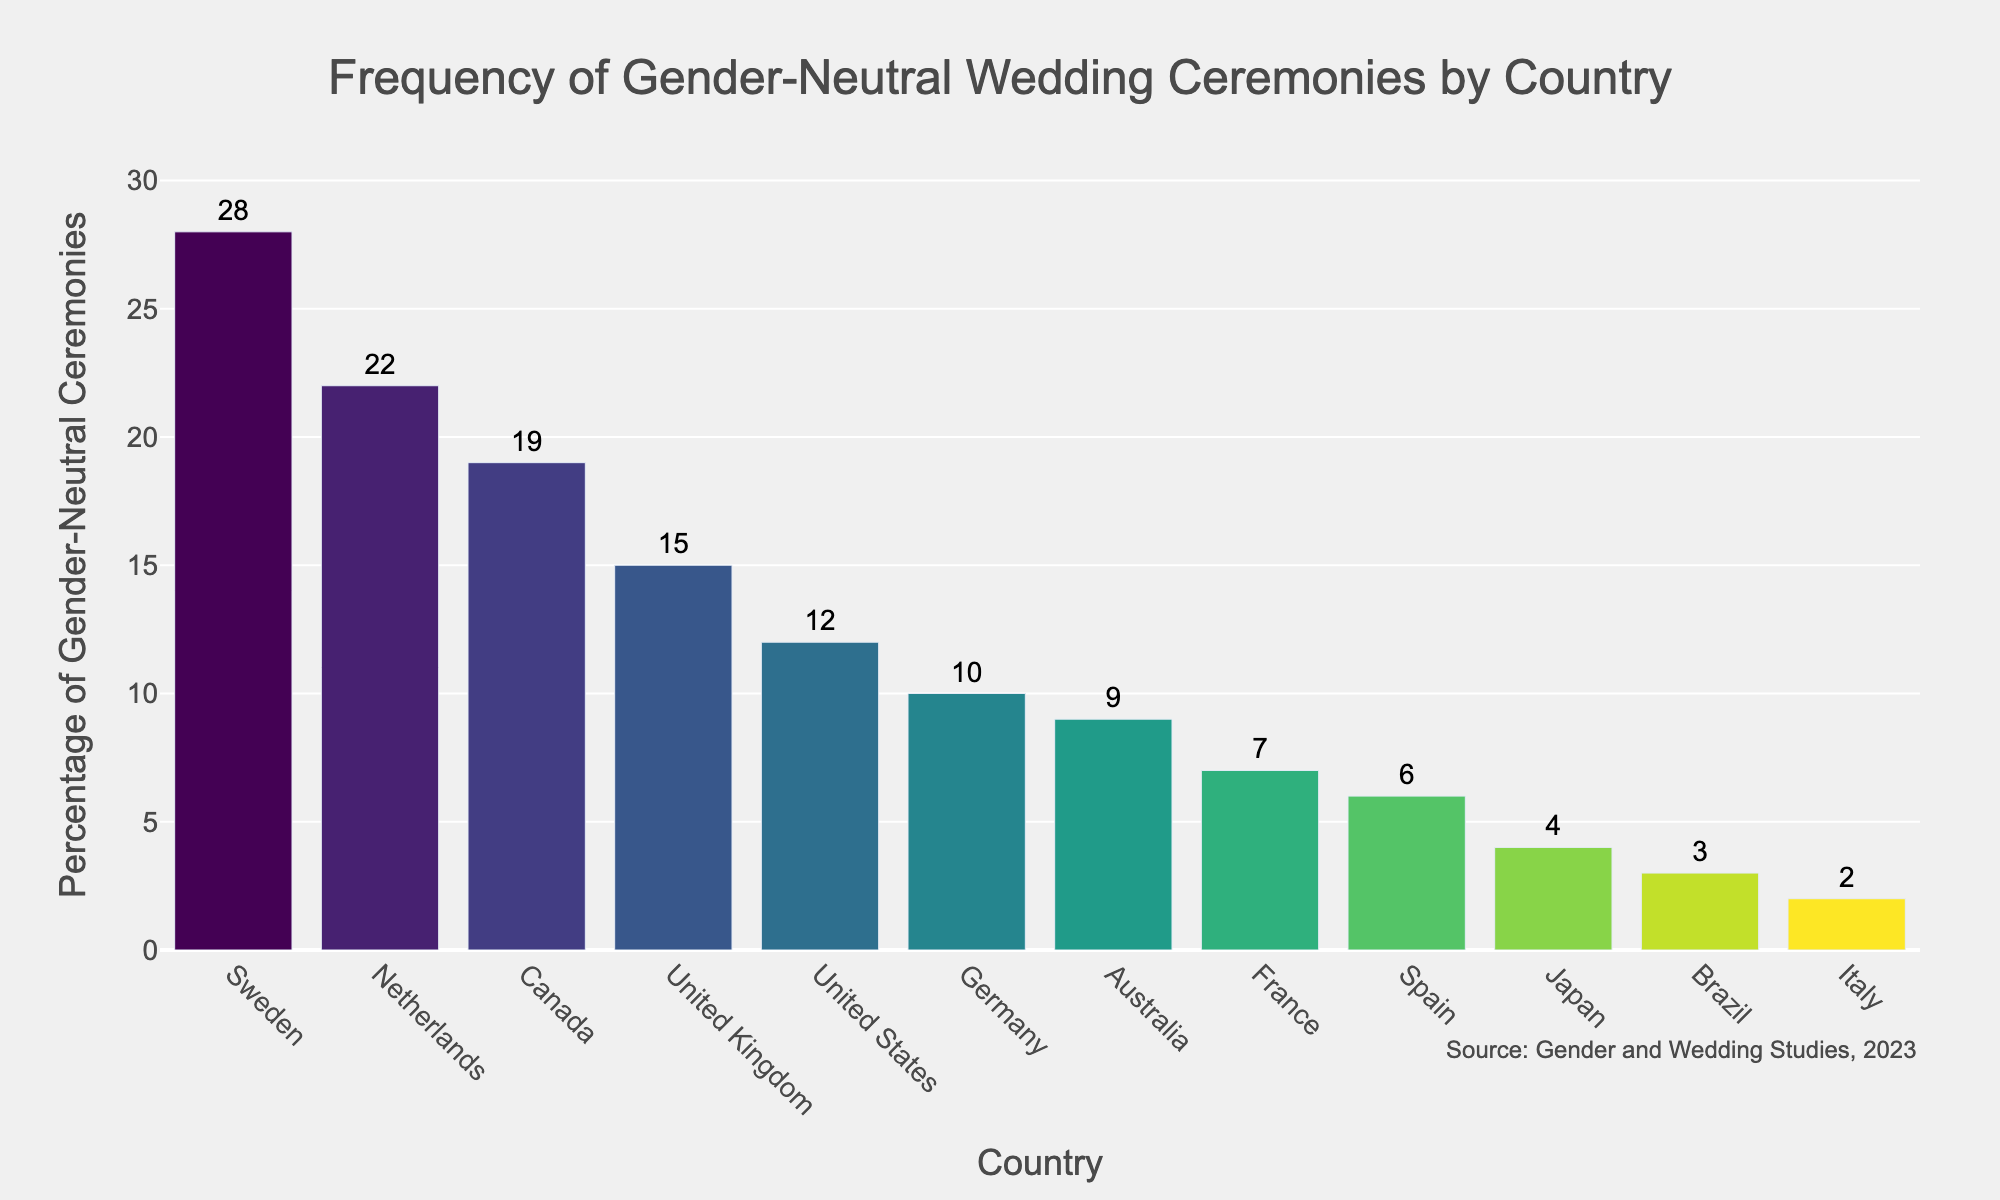What is the title of the figure? The title is located at the top of the figure and provides an overview of what the figure represents. The title of the figure is "Frequency of Gender-Neutral Wedding Ceremonies by Country."
Answer: Frequency of Gender-Neutral Wedding Ceremonies by Country Which country has the highest percentage of gender-neutral wedding ceremonies? By looking at the height of the bars in the histogram, we can see that Sweden has the highest bar. The percentage of gender-neutral wedding ceremonies in Sweden is 28%.
Answer: Sweden What is the percentage of gender-neutral wedding ceremonies in Germany? Locate Germany on the x-axis and then observe the height of its corresponding bar to find the percentage. The bar indicates that Germany has a 10% frequency of gender-neutral wedding ceremonies.
Answer: 10% How many countries have a percentage of gender-neutral wedding ceremonies greater than 10%? Identify which bars reach above the 10% mark on the y-axis. Sweden, Netherlands, Canada, and the United Kingdom have bars above 10%. Thus, there are 4 countries with a percentage greater than 10%.
Answer: 4 What is the sum of the percentages for Canada and the United Kingdom? Locate the bars for Canada and the United Kingdom. Canada has a percentage of 19% and the United Kingdom has 15%. Summing these values: 19 + 15 = 34.
Answer: 34 Which country has a slightly lower percentage of gender-neutral wedding ceremonies than the United Kingdom? Look at the bar next to the United Kingdom, which has a slightly lower height. The United States has a percentage of 12%, which is slightly lower than the United Kingdom's 15%.
Answer: United States What is the difference in percentage between the countries with the highest and lowest frequency of gender-neutral wedding ceremonies? Sweden has the highest percentage with 28%, and Italy has the lowest with 2%. The difference is calculated as 28 - 2 = 26.
Answer: 26 Which country has a 4% frequency of gender-neutral wedding ceremonies? Locate the bar that reaches the 4% mark on the y-axis. The country corresponding to this bar is Japan.
Answer: Japan 